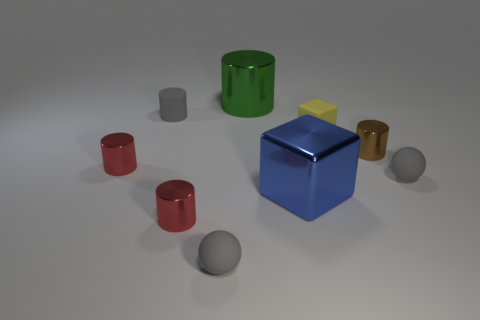Subtract all red spheres. How many red cylinders are left? 2 Subtract all gray cylinders. How many cylinders are left? 4 Subtract 3 cylinders. How many cylinders are left? 2 Subtract all red cylinders. How many cylinders are left? 3 Subtract all red cylinders. Subtract all green balls. How many cylinders are left? 3 Subtract all cylinders. How many objects are left? 4 Add 8 tiny red shiny cylinders. How many tiny red shiny cylinders are left? 10 Add 3 blue metal things. How many blue metal things exist? 4 Subtract 0 purple blocks. How many objects are left? 9 Subtract all large green things. Subtract all large blue metal blocks. How many objects are left? 7 